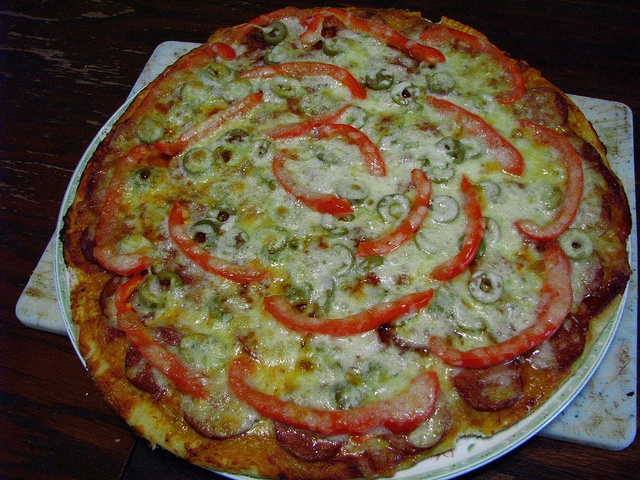Describe the objects in this image and their specific colors. I can see dining table in black, olive, maroon, and darkgray tones and pizza in black, maroon, olive, and darkgray tones in this image. 